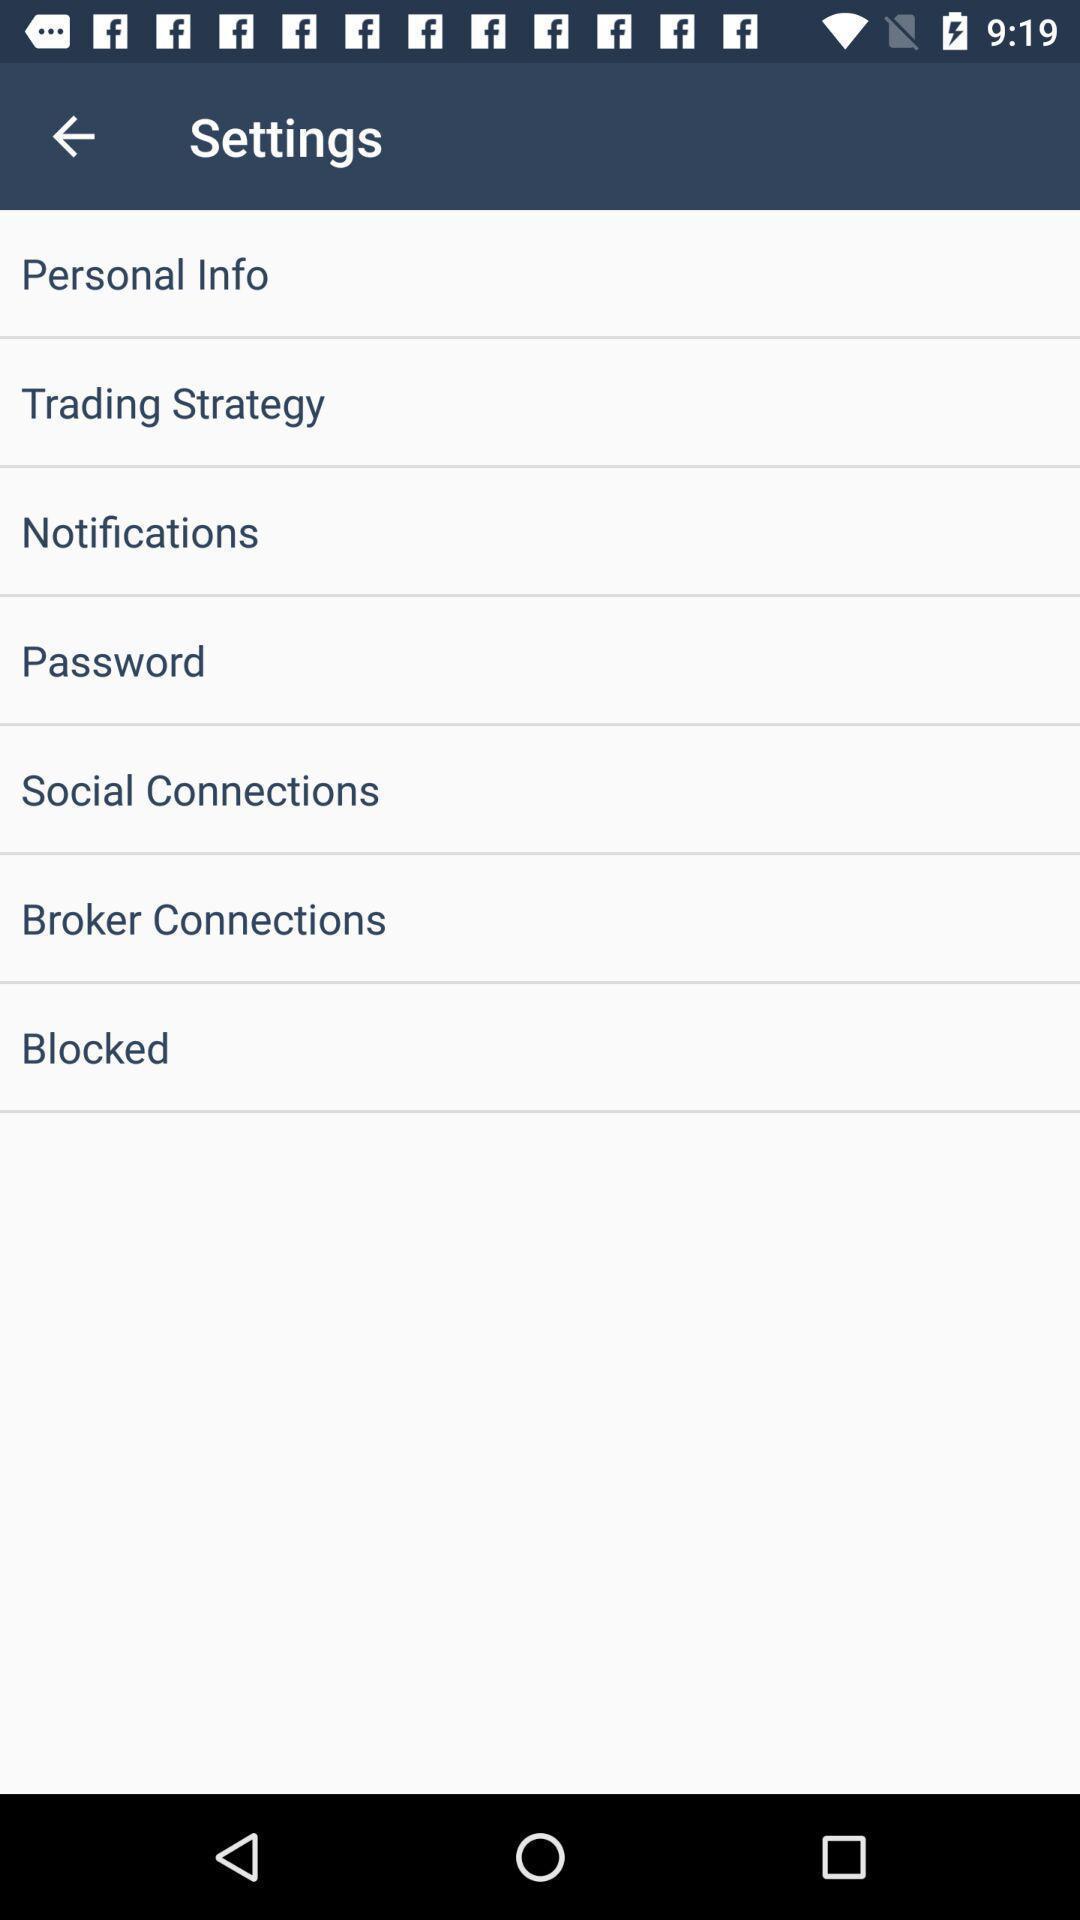Describe this image in words. Settings page with multiple options. 